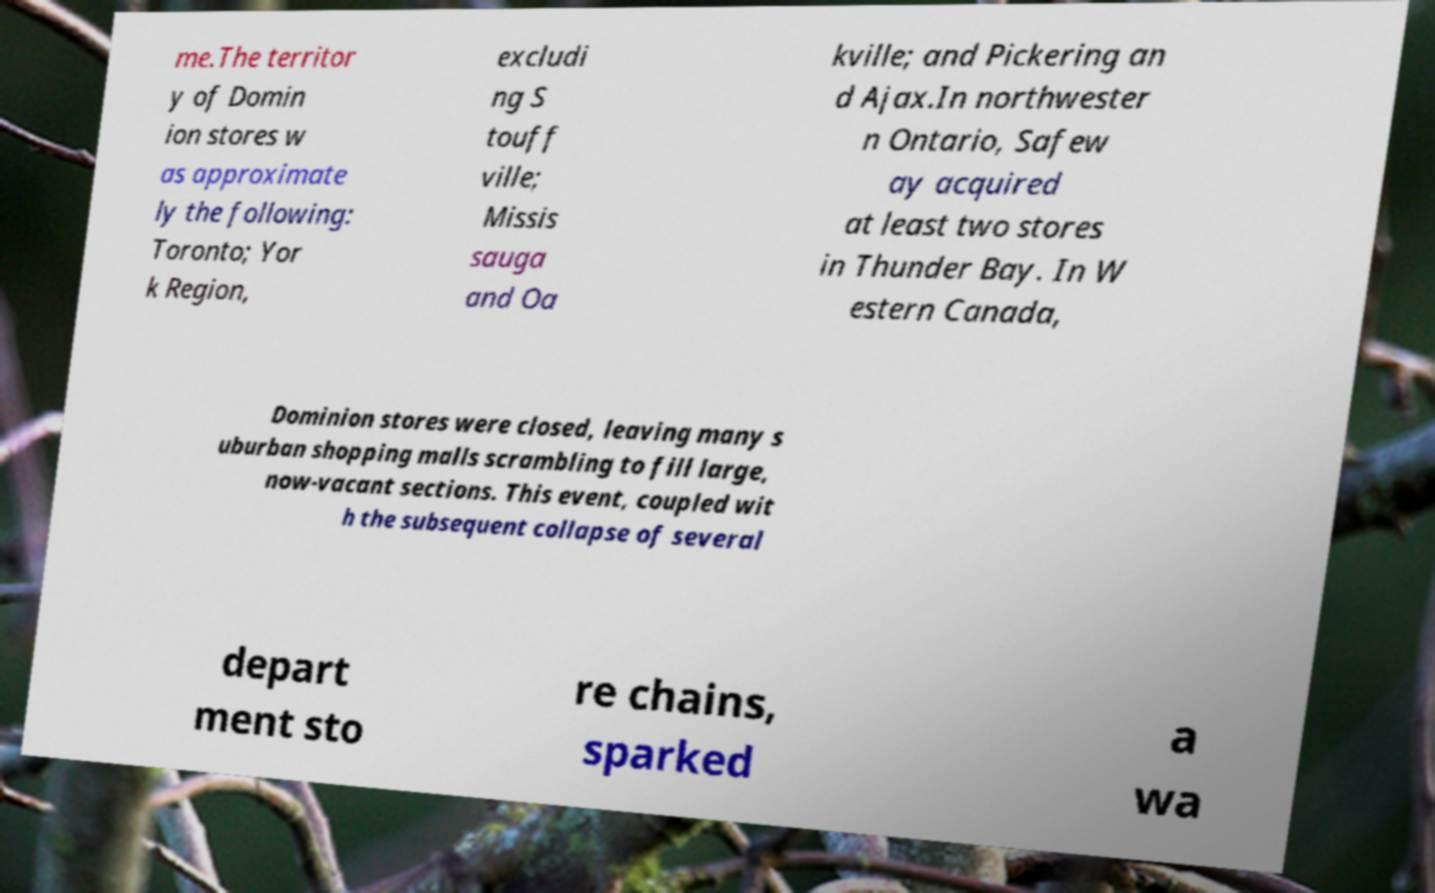What messages or text are displayed in this image? I need them in a readable, typed format. me.The territor y of Domin ion stores w as approximate ly the following: Toronto; Yor k Region, excludi ng S touff ville; Missis sauga and Oa kville; and Pickering an d Ajax.In northwester n Ontario, Safew ay acquired at least two stores in Thunder Bay. In W estern Canada, Dominion stores were closed, leaving many s uburban shopping malls scrambling to fill large, now-vacant sections. This event, coupled wit h the subsequent collapse of several depart ment sto re chains, sparked a wa 